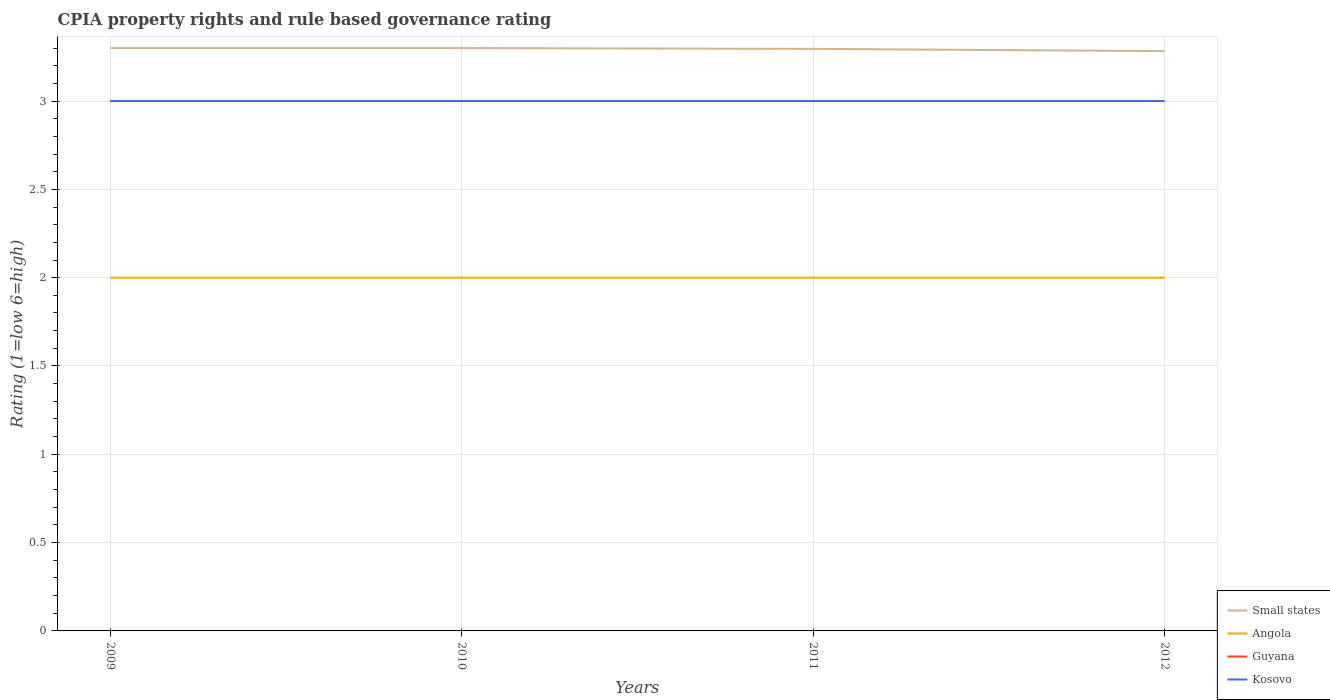Across all years, what is the maximum CPIA rating in Guyana?
Offer a terse response. 3. In which year was the CPIA rating in Kosovo maximum?
Keep it short and to the point. 2009. What is the total CPIA rating in Kosovo in the graph?
Give a very brief answer. 0. What is the difference between the highest and the lowest CPIA rating in Small states?
Your response must be concise. 3. How many years are there in the graph?
Keep it short and to the point. 4. What is the difference between two consecutive major ticks on the Y-axis?
Offer a very short reply. 0.5. Where does the legend appear in the graph?
Offer a terse response. Bottom right. How many legend labels are there?
Provide a short and direct response. 4. What is the title of the graph?
Your answer should be very brief. CPIA property rights and rule based governance rating. What is the label or title of the X-axis?
Your answer should be very brief. Years. What is the label or title of the Y-axis?
Keep it short and to the point. Rating (1=low 6=high). What is the Rating (1=low 6=high) in Guyana in 2009?
Give a very brief answer. 3. What is the Rating (1=low 6=high) in Guyana in 2010?
Offer a terse response. 3. What is the Rating (1=low 6=high) of Small states in 2011?
Make the answer very short. 3.3. What is the Rating (1=low 6=high) in Angola in 2011?
Offer a very short reply. 2. What is the Rating (1=low 6=high) of Small states in 2012?
Your answer should be very brief. 3.28. What is the Rating (1=low 6=high) in Angola in 2012?
Provide a succinct answer. 2. What is the Rating (1=low 6=high) in Guyana in 2012?
Make the answer very short. 3. Across all years, what is the maximum Rating (1=low 6=high) of Angola?
Your answer should be very brief. 2. Across all years, what is the minimum Rating (1=low 6=high) of Small states?
Make the answer very short. 3.28. Across all years, what is the minimum Rating (1=low 6=high) in Angola?
Your answer should be compact. 2. Across all years, what is the minimum Rating (1=low 6=high) of Guyana?
Ensure brevity in your answer.  3. What is the total Rating (1=low 6=high) in Small states in the graph?
Your answer should be compact. 13.18. What is the total Rating (1=low 6=high) in Angola in the graph?
Provide a short and direct response. 8. What is the total Rating (1=low 6=high) of Guyana in the graph?
Ensure brevity in your answer.  12. What is the total Rating (1=low 6=high) in Kosovo in the graph?
Keep it short and to the point. 12. What is the difference between the Rating (1=low 6=high) of Angola in 2009 and that in 2010?
Your answer should be compact. 0. What is the difference between the Rating (1=low 6=high) in Guyana in 2009 and that in 2010?
Give a very brief answer. 0. What is the difference between the Rating (1=low 6=high) in Kosovo in 2009 and that in 2010?
Your response must be concise. 0. What is the difference between the Rating (1=low 6=high) of Small states in 2009 and that in 2011?
Offer a very short reply. 0. What is the difference between the Rating (1=low 6=high) in Angola in 2009 and that in 2011?
Offer a terse response. 0. What is the difference between the Rating (1=low 6=high) in Kosovo in 2009 and that in 2011?
Provide a short and direct response. 0. What is the difference between the Rating (1=low 6=high) in Small states in 2009 and that in 2012?
Offer a very short reply. 0.02. What is the difference between the Rating (1=low 6=high) of Angola in 2009 and that in 2012?
Ensure brevity in your answer.  0. What is the difference between the Rating (1=low 6=high) in Kosovo in 2009 and that in 2012?
Give a very brief answer. 0. What is the difference between the Rating (1=low 6=high) of Small states in 2010 and that in 2011?
Offer a terse response. 0. What is the difference between the Rating (1=low 6=high) of Angola in 2010 and that in 2011?
Provide a succinct answer. 0. What is the difference between the Rating (1=low 6=high) in Kosovo in 2010 and that in 2011?
Provide a short and direct response. 0. What is the difference between the Rating (1=low 6=high) in Small states in 2010 and that in 2012?
Provide a succinct answer. 0.02. What is the difference between the Rating (1=low 6=high) of Angola in 2010 and that in 2012?
Offer a very short reply. 0. What is the difference between the Rating (1=low 6=high) of Kosovo in 2010 and that in 2012?
Your answer should be compact. 0. What is the difference between the Rating (1=low 6=high) in Small states in 2011 and that in 2012?
Make the answer very short. 0.01. What is the difference between the Rating (1=low 6=high) of Angola in 2011 and that in 2012?
Offer a very short reply. 0. What is the difference between the Rating (1=low 6=high) in Guyana in 2011 and that in 2012?
Your answer should be very brief. 0. What is the difference between the Rating (1=low 6=high) of Kosovo in 2011 and that in 2012?
Ensure brevity in your answer.  0. What is the difference between the Rating (1=low 6=high) of Small states in 2009 and the Rating (1=low 6=high) of Angola in 2010?
Ensure brevity in your answer.  1.3. What is the difference between the Rating (1=low 6=high) of Small states in 2009 and the Rating (1=low 6=high) of Guyana in 2010?
Offer a terse response. 0.3. What is the difference between the Rating (1=low 6=high) in Small states in 2009 and the Rating (1=low 6=high) in Kosovo in 2010?
Your response must be concise. 0.3. What is the difference between the Rating (1=low 6=high) of Angola in 2009 and the Rating (1=low 6=high) of Guyana in 2010?
Make the answer very short. -1. What is the difference between the Rating (1=low 6=high) in Small states in 2009 and the Rating (1=low 6=high) in Angola in 2011?
Offer a terse response. 1.3. What is the difference between the Rating (1=low 6=high) in Small states in 2009 and the Rating (1=low 6=high) in Guyana in 2011?
Your response must be concise. 0.3. What is the difference between the Rating (1=low 6=high) of Small states in 2009 and the Rating (1=low 6=high) of Kosovo in 2011?
Give a very brief answer. 0.3. What is the difference between the Rating (1=low 6=high) of Angola in 2009 and the Rating (1=low 6=high) of Guyana in 2011?
Your response must be concise. -1. What is the difference between the Rating (1=low 6=high) of Angola in 2009 and the Rating (1=low 6=high) of Kosovo in 2011?
Ensure brevity in your answer.  -1. What is the difference between the Rating (1=low 6=high) of Small states in 2009 and the Rating (1=low 6=high) of Kosovo in 2012?
Your response must be concise. 0.3. What is the difference between the Rating (1=low 6=high) in Angola in 2009 and the Rating (1=low 6=high) in Guyana in 2012?
Ensure brevity in your answer.  -1. What is the difference between the Rating (1=low 6=high) of Angola in 2009 and the Rating (1=low 6=high) of Kosovo in 2012?
Keep it short and to the point. -1. What is the difference between the Rating (1=low 6=high) in Guyana in 2009 and the Rating (1=low 6=high) in Kosovo in 2012?
Your answer should be very brief. 0. What is the difference between the Rating (1=low 6=high) in Small states in 2010 and the Rating (1=low 6=high) in Guyana in 2011?
Provide a short and direct response. 0.3. What is the difference between the Rating (1=low 6=high) of Guyana in 2010 and the Rating (1=low 6=high) of Kosovo in 2011?
Provide a succinct answer. 0. What is the difference between the Rating (1=low 6=high) in Small states in 2010 and the Rating (1=low 6=high) in Angola in 2012?
Offer a very short reply. 1.3. What is the difference between the Rating (1=low 6=high) of Small states in 2010 and the Rating (1=low 6=high) of Kosovo in 2012?
Provide a short and direct response. 0.3. What is the difference between the Rating (1=low 6=high) of Angola in 2010 and the Rating (1=low 6=high) of Guyana in 2012?
Offer a very short reply. -1. What is the difference between the Rating (1=low 6=high) in Small states in 2011 and the Rating (1=low 6=high) in Angola in 2012?
Give a very brief answer. 1.3. What is the difference between the Rating (1=low 6=high) of Small states in 2011 and the Rating (1=low 6=high) of Guyana in 2012?
Give a very brief answer. 0.3. What is the difference between the Rating (1=low 6=high) of Small states in 2011 and the Rating (1=low 6=high) of Kosovo in 2012?
Provide a succinct answer. 0.3. What is the difference between the Rating (1=low 6=high) in Angola in 2011 and the Rating (1=low 6=high) in Kosovo in 2012?
Give a very brief answer. -1. What is the average Rating (1=low 6=high) of Small states per year?
Give a very brief answer. 3.29. What is the average Rating (1=low 6=high) in Angola per year?
Provide a succinct answer. 2. In the year 2009, what is the difference between the Rating (1=low 6=high) of Small states and Rating (1=low 6=high) of Kosovo?
Provide a short and direct response. 0.3. In the year 2010, what is the difference between the Rating (1=low 6=high) in Small states and Rating (1=low 6=high) in Angola?
Your answer should be very brief. 1.3. In the year 2011, what is the difference between the Rating (1=low 6=high) in Small states and Rating (1=low 6=high) in Angola?
Keep it short and to the point. 1.3. In the year 2011, what is the difference between the Rating (1=low 6=high) of Small states and Rating (1=low 6=high) of Guyana?
Offer a very short reply. 0.3. In the year 2011, what is the difference between the Rating (1=low 6=high) of Small states and Rating (1=low 6=high) of Kosovo?
Your answer should be compact. 0.3. In the year 2011, what is the difference between the Rating (1=low 6=high) in Angola and Rating (1=low 6=high) in Guyana?
Offer a very short reply. -1. In the year 2011, what is the difference between the Rating (1=low 6=high) in Angola and Rating (1=low 6=high) in Kosovo?
Make the answer very short. -1. In the year 2011, what is the difference between the Rating (1=low 6=high) in Guyana and Rating (1=low 6=high) in Kosovo?
Give a very brief answer. 0. In the year 2012, what is the difference between the Rating (1=low 6=high) in Small states and Rating (1=low 6=high) in Angola?
Your answer should be compact. 1.28. In the year 2012, what is the difference between the Rating (1=low 6=high) of Small states and Rating (1=low 6=high) of Guyana?
Ensure brevity in your answer.  0.28. In the year 2012, what is the difference between the Rating (1=low 6=high) of Small states and Rating (1=low 6=high) of Kosovo?
Ensure brevity in your answer.  0.28. In the year 2012, what is the difference between the Rating (1=low 6=high) in Angola and Rating (1=low 6=high) in Guyana?
Provide a short and direct response. -1. In the year 2012, what is the difference between the Rating (1=low 6=high) of Guyana and Rating (1=low 6=high) of Kosovo?
Your response must be concise. 0. What is the ratio of the Rating (1=low 6=high) of Small states in 2009 to that in 2010?
Offer a very short reply. 1. What is the ratio of the Rating (1=low 6=high) of Angola in 2009 to that in 2010?
Make the answer very short. 1. What is the ratio of the Rating (1=low 6=high) of Guyana in 2009 to that in 2011?
Your answer should be very brief. 1. What is the ratio of the Rating (1=low 6=high) of Kosovo in 2009 to that in 2011?
Provide a short and direct response. 1. What is the ratio of the Rating (1=low 6=high) of Small states in 2009 to that in 2012?
Keep it short and to the point. 1.01. What is the ratio of the Rating (1=low 6=high) of Angola in 2009 to that in 2012?
Provide a short and direct response. 1. What is the ratio of the Rating (1=low 6=high) in Guyana in 2009 to that in 2012?
Your answer should be compact. 1. What is the ratio of the Rating (1=low 6=high) in Kosovo in 2009 to that in 2012?
Offer a very short reply. 1. What is the ratio of the Rating (1=low 6=high) in Angola in 2010 to that in 2011?
Offer a very short reply. 1. What is the ratio of the Rating (1=low 6=high) of Angola in 2010 to that in 2012?
Your answer should be very brief. 1. What is the ratio of the Rating (1=low 6=high) in Guyana in 2011 to that in 2012?
Keep it short and to the point. 1. What is the difference between the highest and the second highest Rating (1=low 6=high) in Small states?
Your answer should be compact. 0. What is the difference between the highest and the second highest Rating (1=low 6=high) in Kosovo?
Your response must be concise. 0. What is the difference between the highest and the lowest Rating (1=low 6=high) in Small states?
Give a very brief answer. 0.02. What is the difference between the highest and the lowest Rating (1=low 6=high) in Kosovo?
Offer a very short reply. 0. 